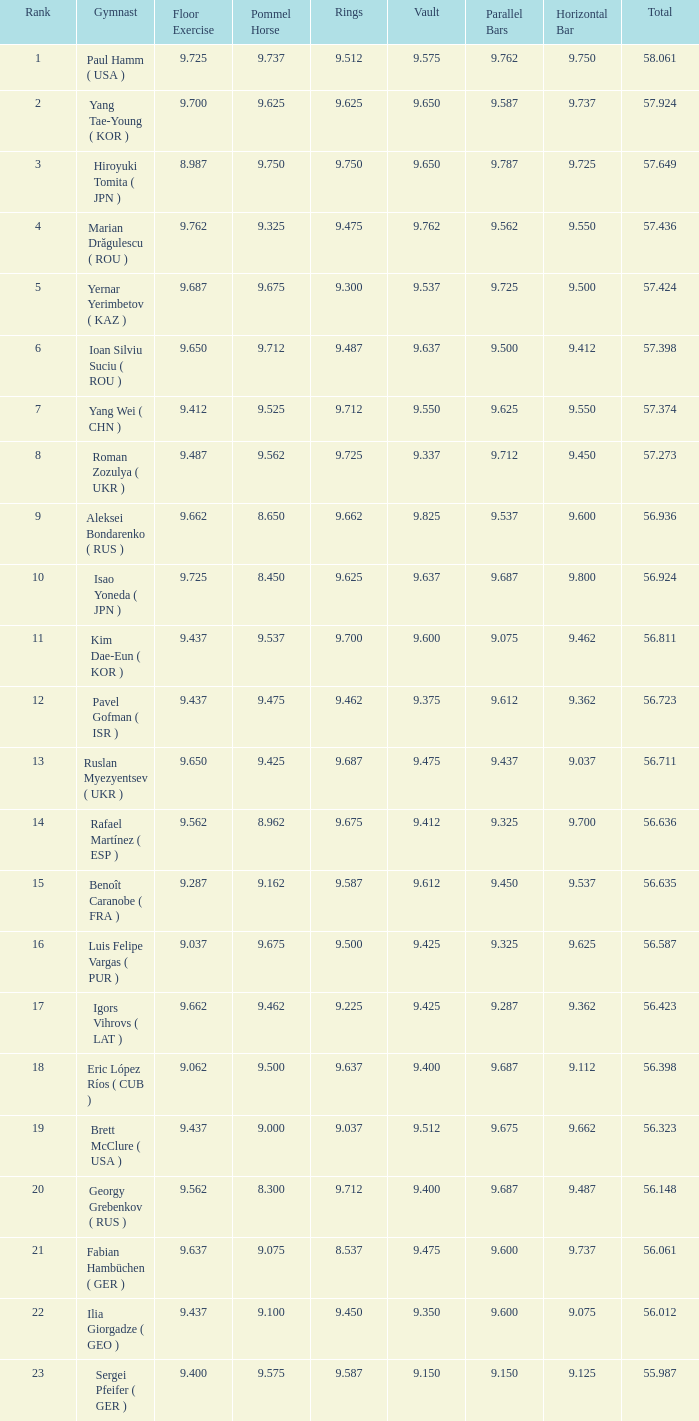Write the full table. {'header': ['Rank', 'Gymnast', 'Floor Exercise', 'Pommel Horse', 'Rings', 'Vault', 'Parallel Bars', 'Horizontal Bar', 'Total'], 'rows': [['1', 'Paul Hamm ( USA )', '9.725', '9.737', '9.512', '9.575', '9.762', '9.750', '58.061'], ['2', 'Yang Tae-Young ( KOR )', '9.700', '9.625', '9.625', '9.650', '9.587', '9.737', '57.924'], ['3', 'Hiroyuki Tomita ( JPN )', '8.987', '9.750', '9.750', '9.650', '9.787', '9.725', '57.649'], ['4', 'Marian Drăgulescu ( ROU )', '9.762', '9.325', '9.475', '9.762', '9.562', '9.550', '57.436'], ['5', 'Yernar Yerimbetov ( KAZ )', '9.687', '9.675', '9.300', '9.537', '9.725', '9.500', '57.424'], ['6', 'Ioan Silviu Suciu ( ROU )', '9.650', '9.712', '9.487', '9.637', '9.500', '9.412', '57.398'], ['7', 'Yang Wei ( CHN )', '9.412', '9.525', '9.712', '9.550', '9.625', '9.550', '57.374'], ['8', 'Roman Zozulya ( UKR )', '9.487', '9.562', '9.725', '9.337', '9.712', '9.450', '57.273'], ['9', 'Aleksei Bondarenko ( RUS )', '9.662', '8.650', '9.662', '9.825', '9.537', '9.600', '56.936'], ['10', 'Isao Yoneda ( JPN )', '9.725', '8.450', '9.625', '9.637', '9.687', '9.800', '56.924'], ['11', 'Kim Dae-Eun ( KOR )', '9.437', '9.537', '9.700', '9.600', '9.075', '9.462', '56.811'], ['12', 'Pavel Gofman ( ISR )', '9.437', '9.475', '9.462', '9.375', '9.612', '9.362', '56.723'], ['13', 'Ruslan Myezyentsev ( UKR )', '9.650', '9.425', '9.687', '9.475', '9.437', '9.037', '56.711'], ['14', 'Rafael Martínez ( ESP )', '9.562', '8.962', '9.675', '9.412', '9.325', '9.700', '56.636'], ['15', 'Benoît Caranobe ( FRA )', '9.287', '9.162', '9.587', '9.612', '9.450', '9.537', '56.635'], ['16', 'Luis Felipe Vargas ( PUR )', '9.037', '9.675', '9.500', '9.425', '9.325', '9.625', '56.587'], ['17', 'Igors Vihrovs ( LAT )', '9.662', '9.462', '9.225', '9.425', '9.287', '9.362', '56.423'], ['18', 'Eric López Ríos ( CUB )', '9.062', '9.500', '9.637', '9.400', '9.687', '9.112', '56.398'], ['19', 'Brett McClure ( USA )', '9.437', '9.000', '9.037', '9.512', '9.675', '9.662', '56.323'], ['20', 'Georgy Grebenkov ( RUS )', '9.562', '8.300', '9.712', '9.400', '9.687', '9.487', '56.148'], ['21', 'Fabian Hambüchen ( GER )', '9.637', '9.075', '8.537', '9.475', '9.600', '9.737', '56.061'], ['22', 'Ilia Giorgadze ( GEO )', '9.437', '9.100', '9.450', '9.350', '9.600', '9.075', '56.012'], ['23', 'Sergei Pfeifer ( GER )', '9.400', '9.575', '9.587', '9.150', '9.150', '9.125', '55.987']]} What is the total vault score equivalent to 56.635? 9.612. 